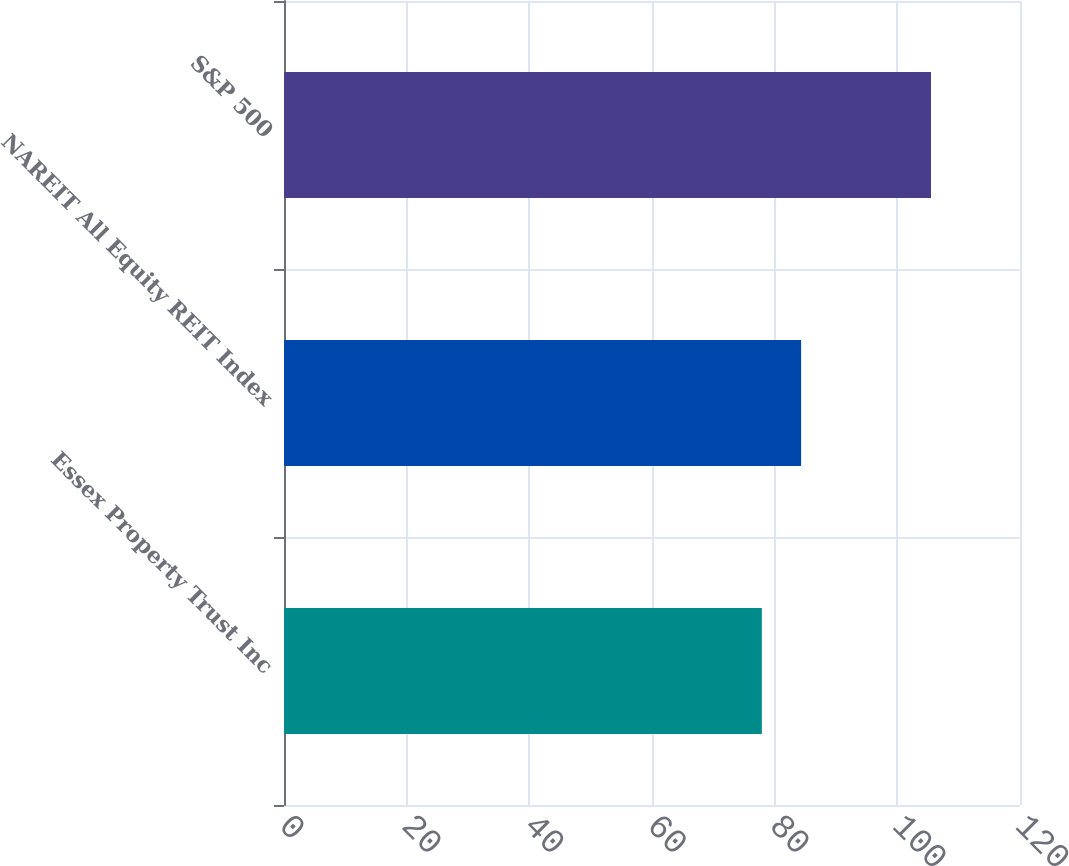Convert chart to OTSL. <chart><loc_0><loc_0><loc_500><loc_500><bar_chart><fcel>Essex Property Trust Inc<fcel>NAREIT All Equity REIT Index<fcel>S&P 500<nl><fcel>77.91<fcel>84.31<fcel>105.49<nl></chart> 